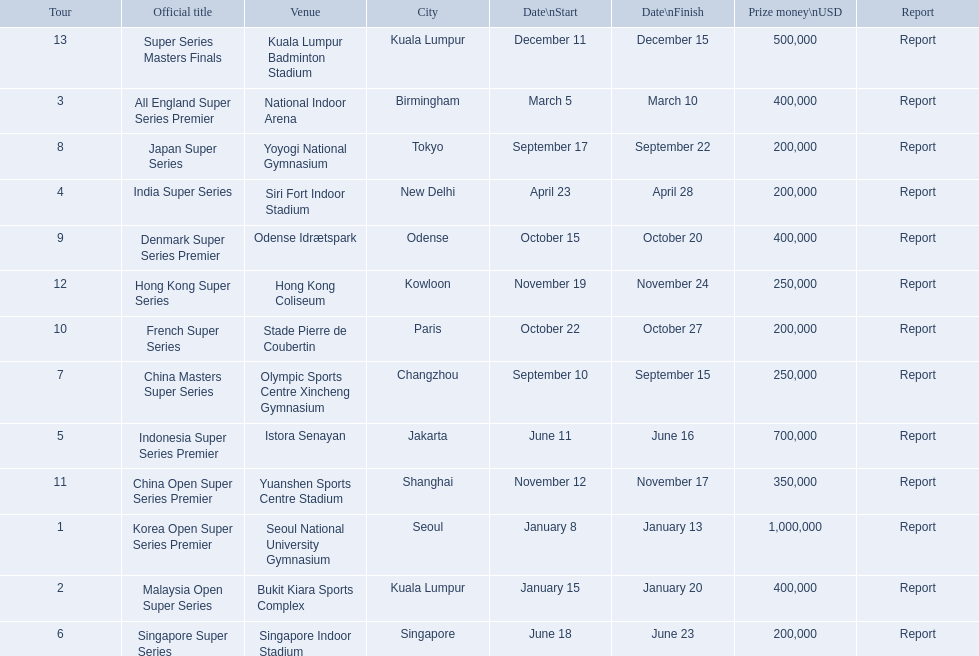What are all the tours? Korea Open Super Series Premier, Malaysia Open Super Series, All England Super Series Premier, India Super Series, Indonesia Super Series Premier, Singapore Super Series, China Masters Super Series, Japan Super Series, Denmark Super Series Premier, French Super Series, China Open Super Series Premier, Hong Kong Super Series, Super Series Masters Finals. What were the start dates of these tours? January 8, January 15, March 5, April 23, June 11, June 18, September 10, September 17, October 15, October 22, November 12, November 19, December 11. Of these, which is in december? December 11. Which tour started on this date? Super Series Masters Finals. 